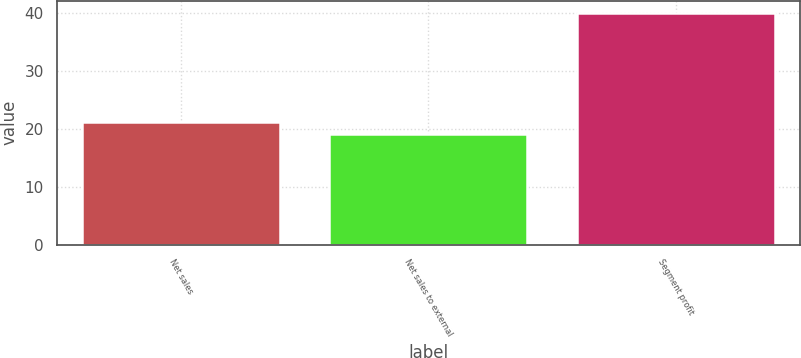Convert chart to OTSL. <chart><loc_0><loc_0><loc_500><loc_500><bar_chart><fcel>Net sales<fcel>Net sales to external<fcel>Segment profit<nl><fcel>21.1<fcel>19<fcel>40<nl></chart> 